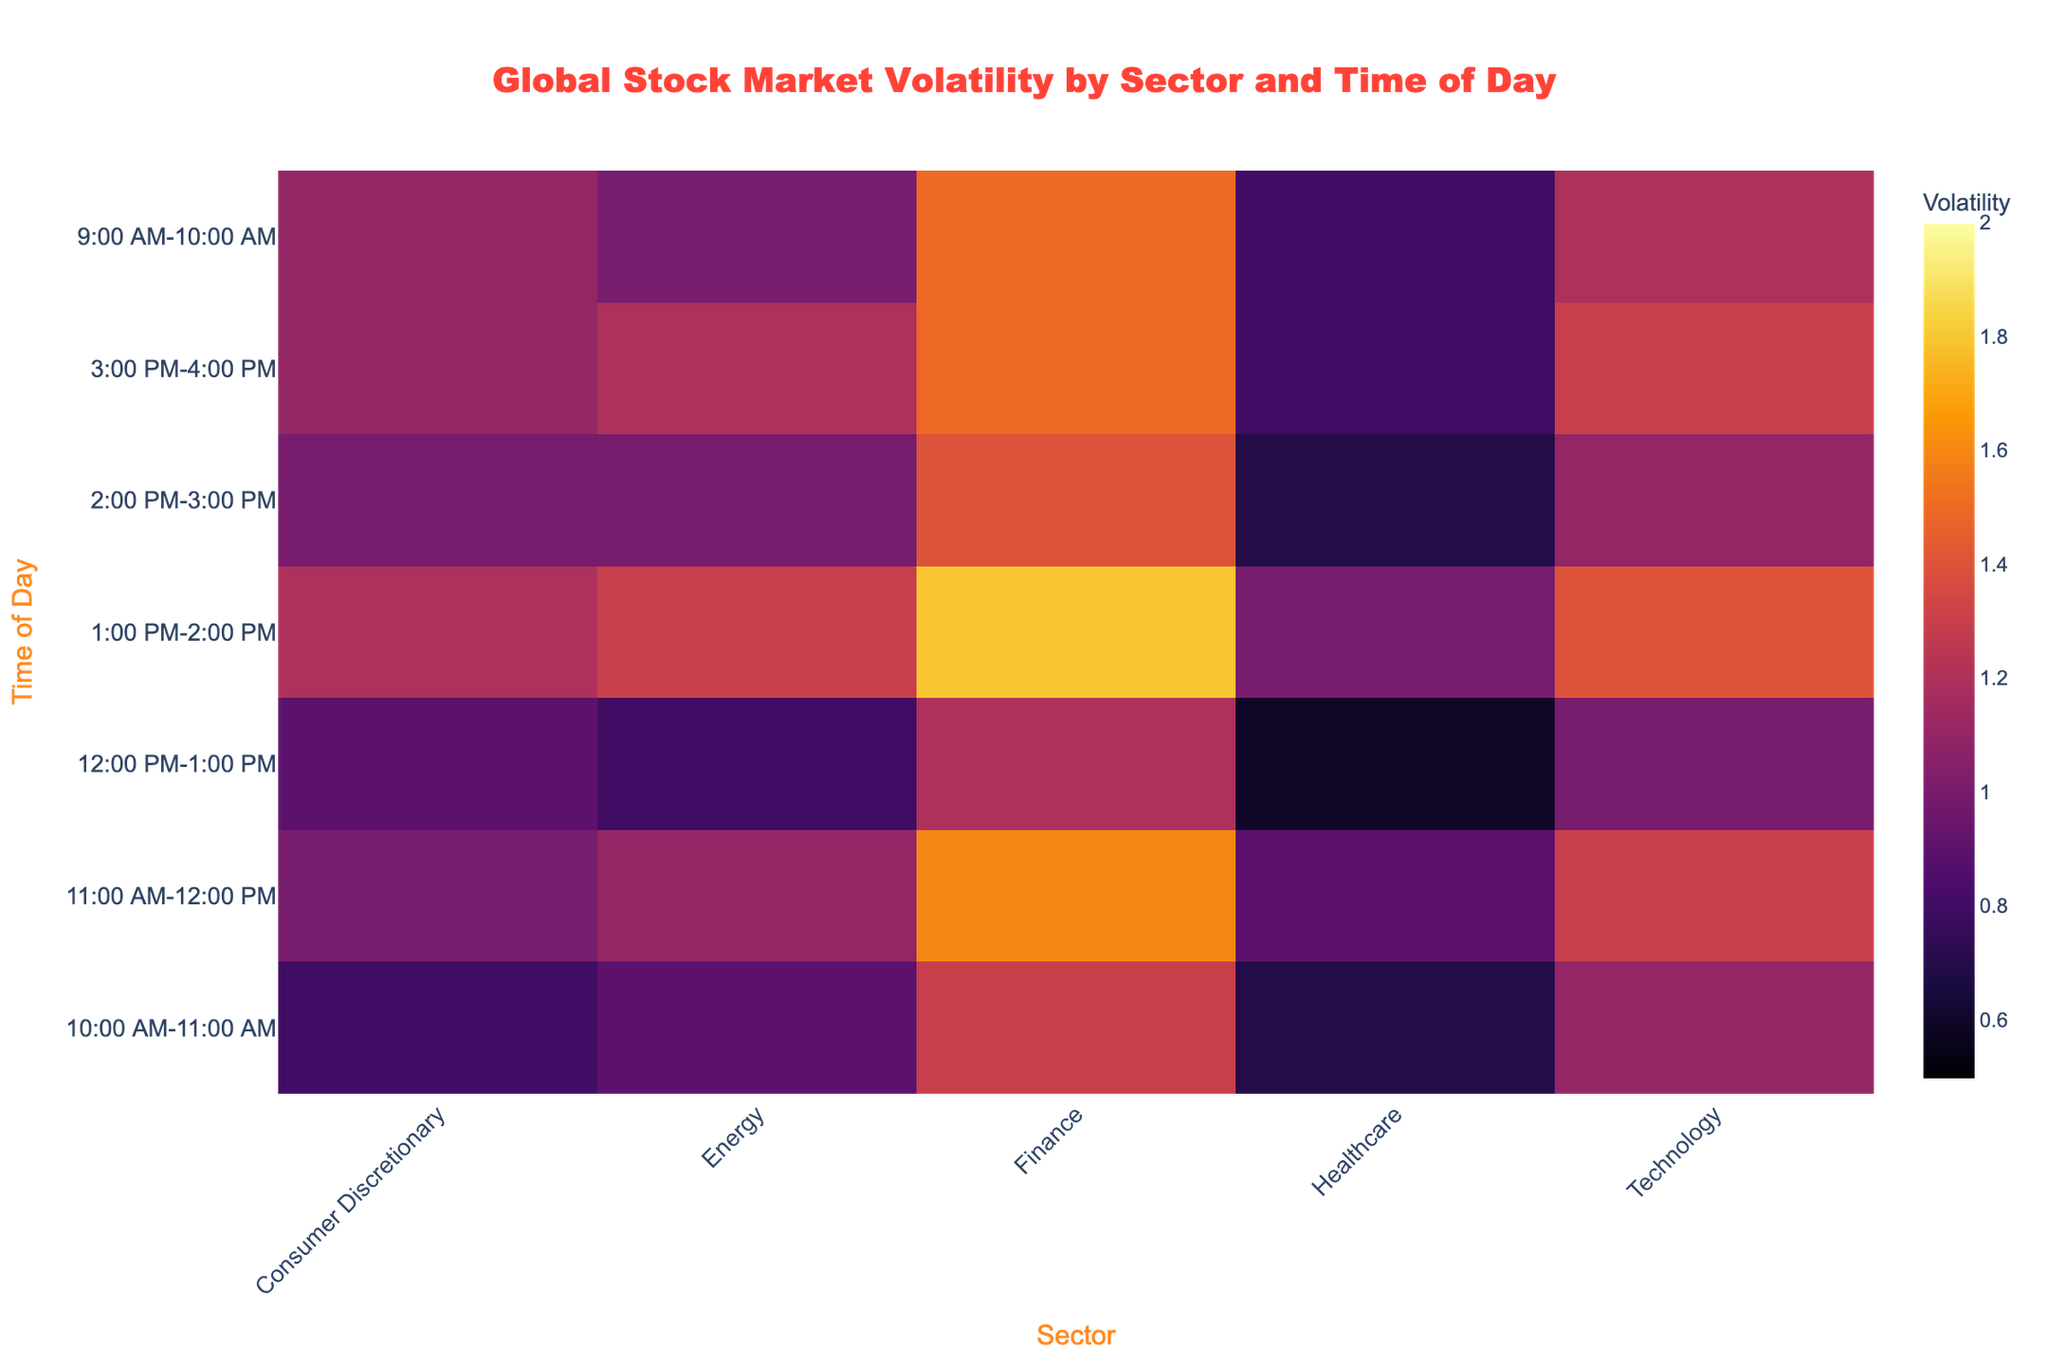What is the title of the heatmap? The title is displayed at the top center of the figure and provides a summary of what the heatmap represents.
Answer: Global Stock Market Volatility by Sector and Time of Day Which sector has the highest volatility between 11:00 AM and 12:00 PM? Locate the row for the time period 11:00 AM - 12:00 PM, then find the column with the highest value.
Answer: Finance At what time does the healthcare sector show the lowest volatility? Find the column for Healthcare and identify the row with the lowest value.
Answer: 12:00 PM-1:00 PM How does the volatility of the Technology sector at 1:00 PM-2:00 PM compare to 12:00 PM-1:00 PM? Compare the values in the Technology column for the two specified time periods.
Answer: Higher What is the average volatility of the Energy sector across all time periods? Find all the values in the Energy column and calculate the average: (1.0 + 0.9 + 1.1 + 0.8 + 1.3 + 1.0 + 1.2) / 7.
Answer: 1.04 Which sector shows the most consistent volatility throughout the day? Evaluate the range of volatility values for each sector, the smallest range indicates the most consistent volatility.
Answer: Healthcare At what time is the Consumer Discretionary sector's volatility greater than 1.1? Identify the rows in the Consumer Discretionary column where the value exceeds 1.1.
Answer: 1:00 PM-2:00 PM Is there any time period where all sectors show volatility less than 1.0? Check each row to see if all values are less than 1.0 for a specific time period.
Answer: No Which sector shows the highest volatility at 10:00 AM - 11:00 AM? Locate the row for 10:00 AM - 11:00 AM and find the highest value in that row.
Answer: Finance 